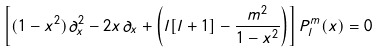<formula> <loc_0><loc_0><loc_500><loc_500>\left [ ( 1 - x ^ { 2 } ) \partial ^ { 2 } _ { x } - 2 x \partial _ { x } + \left ( l [ l + 1 ] - \frac { m ^ { 2 } } { 1 - x ^ { 2 } } \right ) \right ] P ^ { m } _ { l } ( x ) = 0</formula> 